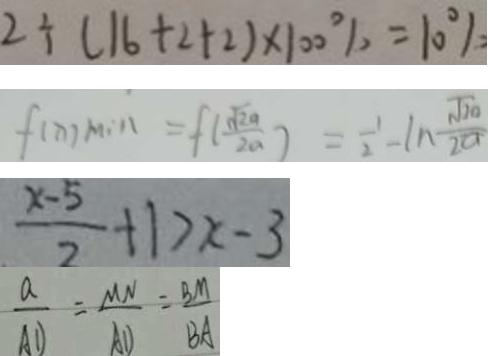Convert formula to latex. <formula><loc_0><loc_0><loc_500><loc_500>2 \div ( 1 6 + 2 + 2 ) \times 1 0 0 \% = 1 0 \% 
 f ( x ) \min = f ( \frac { \sqrt { 2 a } } { 2 a } ) = \frac { 1 } { 2 } - \ln \frac { \sqrt { 2 a } } { 2 a } 
 \frac { x - 5 } { 2 } + 1 > x - 3 
 \frac { a } { A D } = \frac { M N } { A D } = \frac { B M } { B A }</formula> 